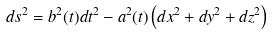<formula> <loc_0><loc_0><loc_500><loc_500>d s ^ { 2 } = b ^ { 2 } ( t ) d t ^ { 2 } - a ^ { 2 } ( t ) \left ( d x ^ { 2 } + d y ^ { 2 } + d z ^ { 2 } \right )</formula> 